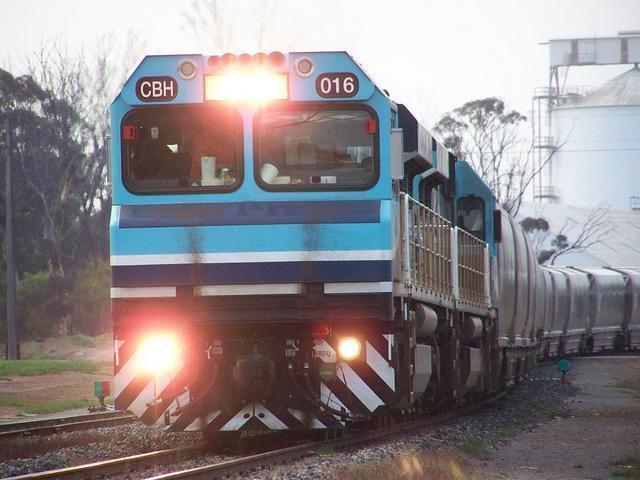How many trains are in the photo?
Give a very brief answer. 1. 